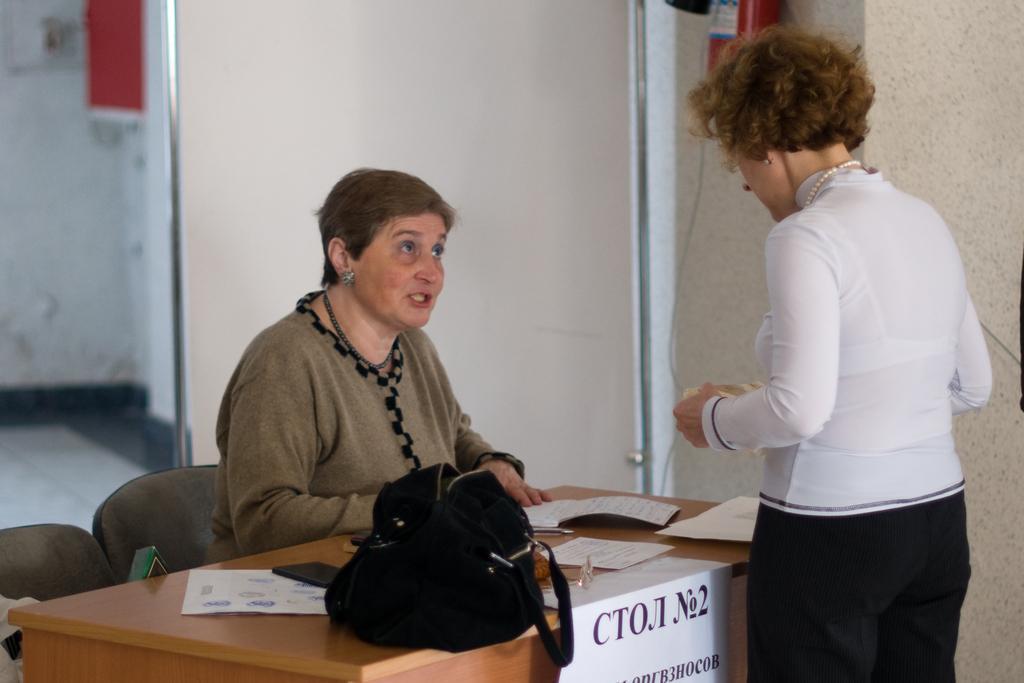Describe this image in one or two sentences. This picture is taken inside the room. In this image, on the right side, we can see a woman wearing a white color shirt and some object in her hand is standing in front of the table, on the table, we can see a bag which is in black color, mobile, papers, books. In the left corner, we can see a chair. In the middle of the image, we can see a woman sitting on the chair in front of the table. In the background, we can see a fire extinguisher, wall. 